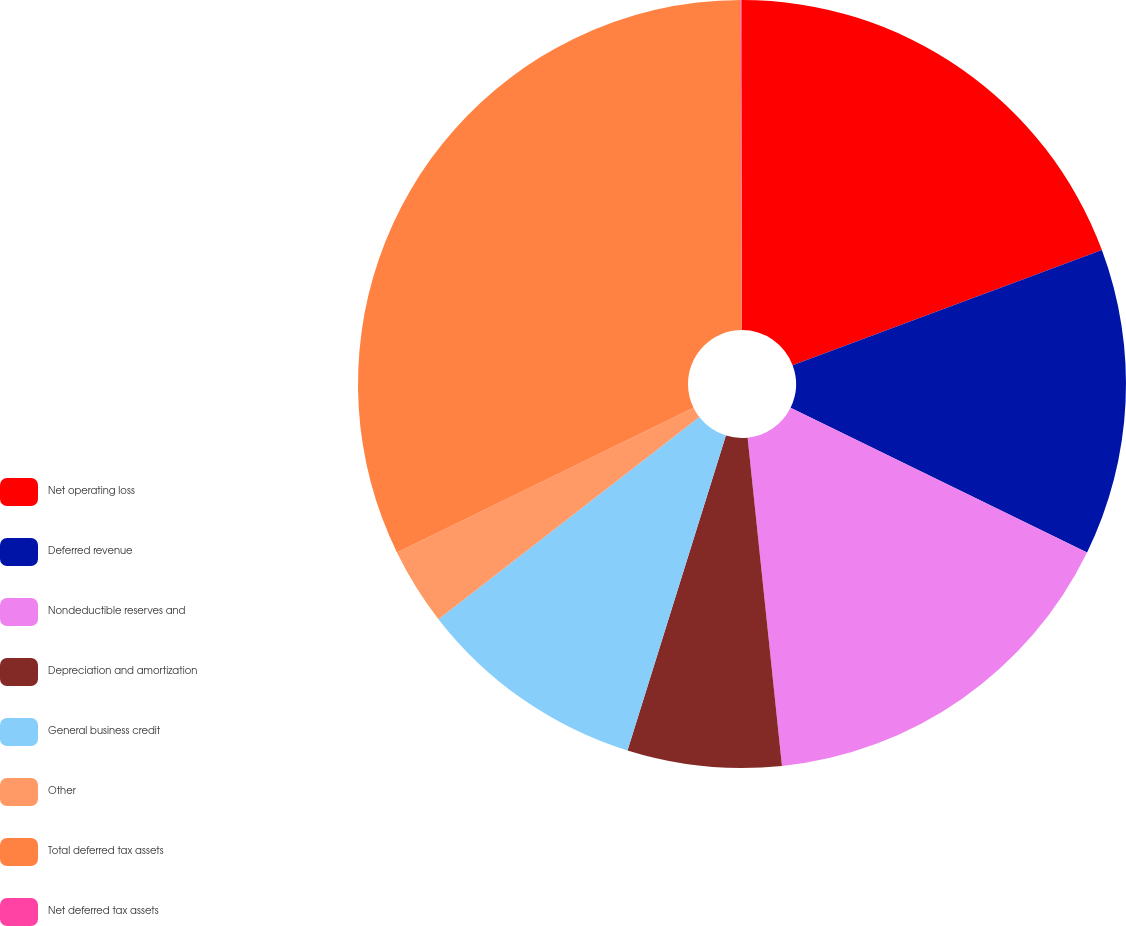Convert chart. <chart><loc_0><loc_0><loc_500><loc_500><pie_chart><fcel>Net operating loss<fcel>Deferred revenue<fcel>Nondeductible reserves and<fcel>Depreciation and amortization<fcel>General business credit<fcel>Other<fcel>Total deferred tax assets<fcel>Net deferred tax assets<nl><fcel>19.33%<fcel>12.9%<fcel>16.11%<fcel>6.48%<fcel>9.69%<fcel>3.26%<fcel>32.18%<fcel>0.05%<nl></chart> 